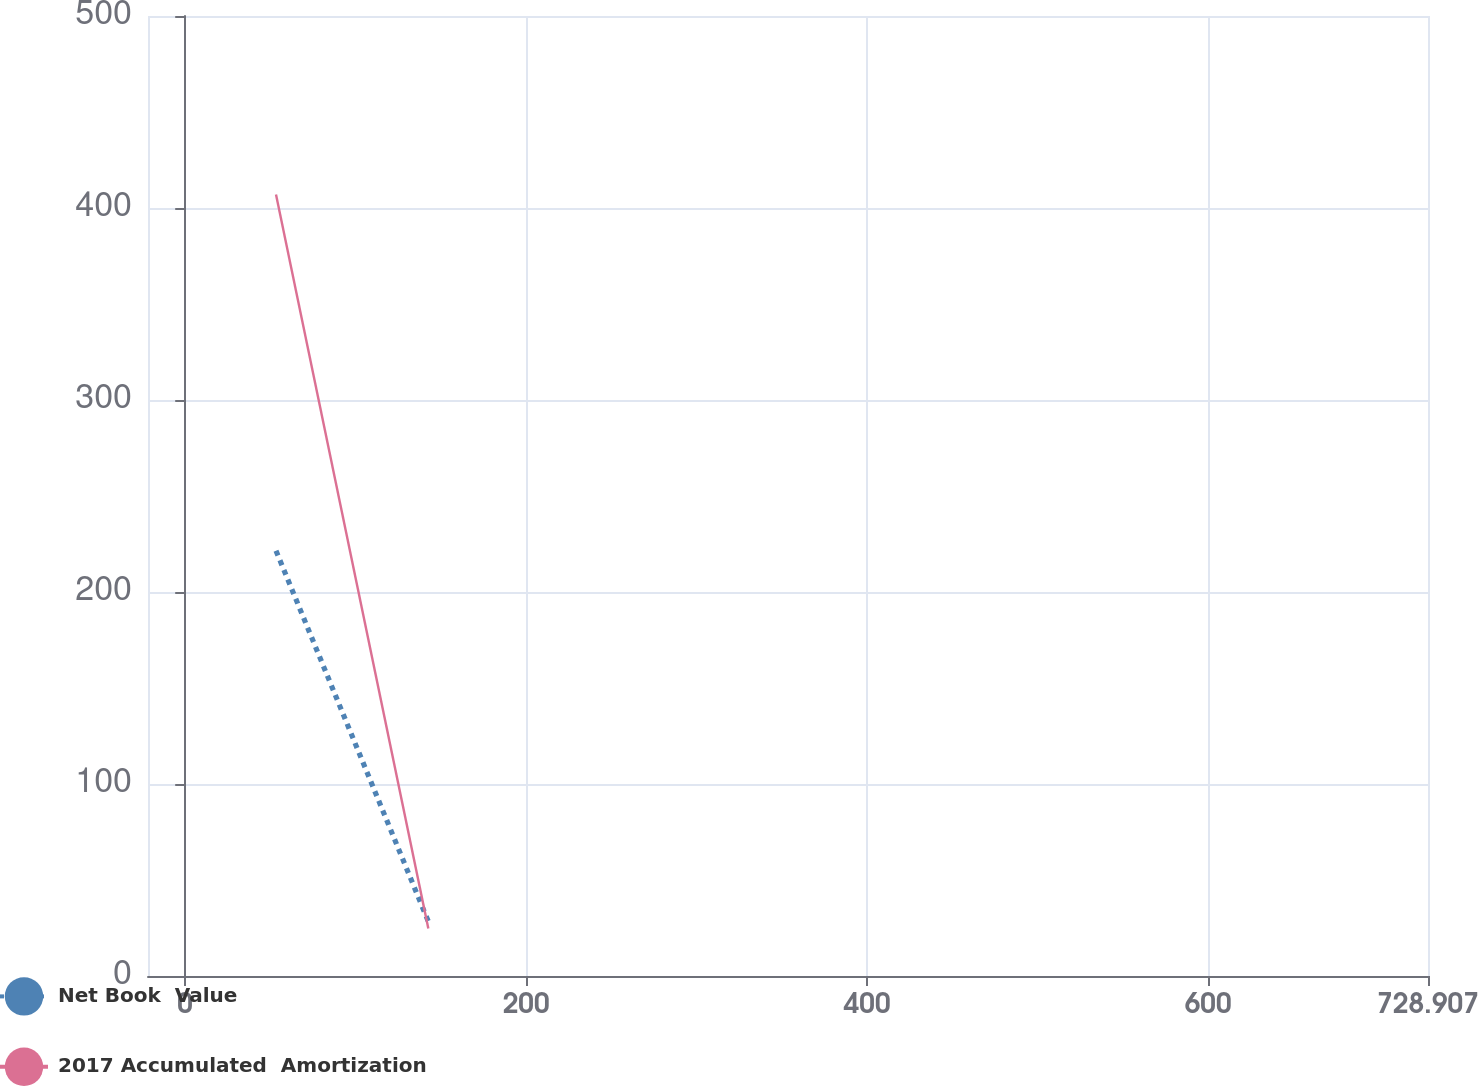<chart> <loc_0><loc_0><loc_500><loc_500><line_chart><ecel><fcel>Net Book  Value<fcel>2017 Accumulated  Amortization<nl><fcel>53.25<fcel>221.5<fcel>407.02<nl><fcel>142.6<fcel>28.38<fcel>24.73<nl><fcel>730.84<fcel>101.69<fcel>74.94<nl><fcel>803.98<fcel>333.9<fcel>526.86<nl></chart> 